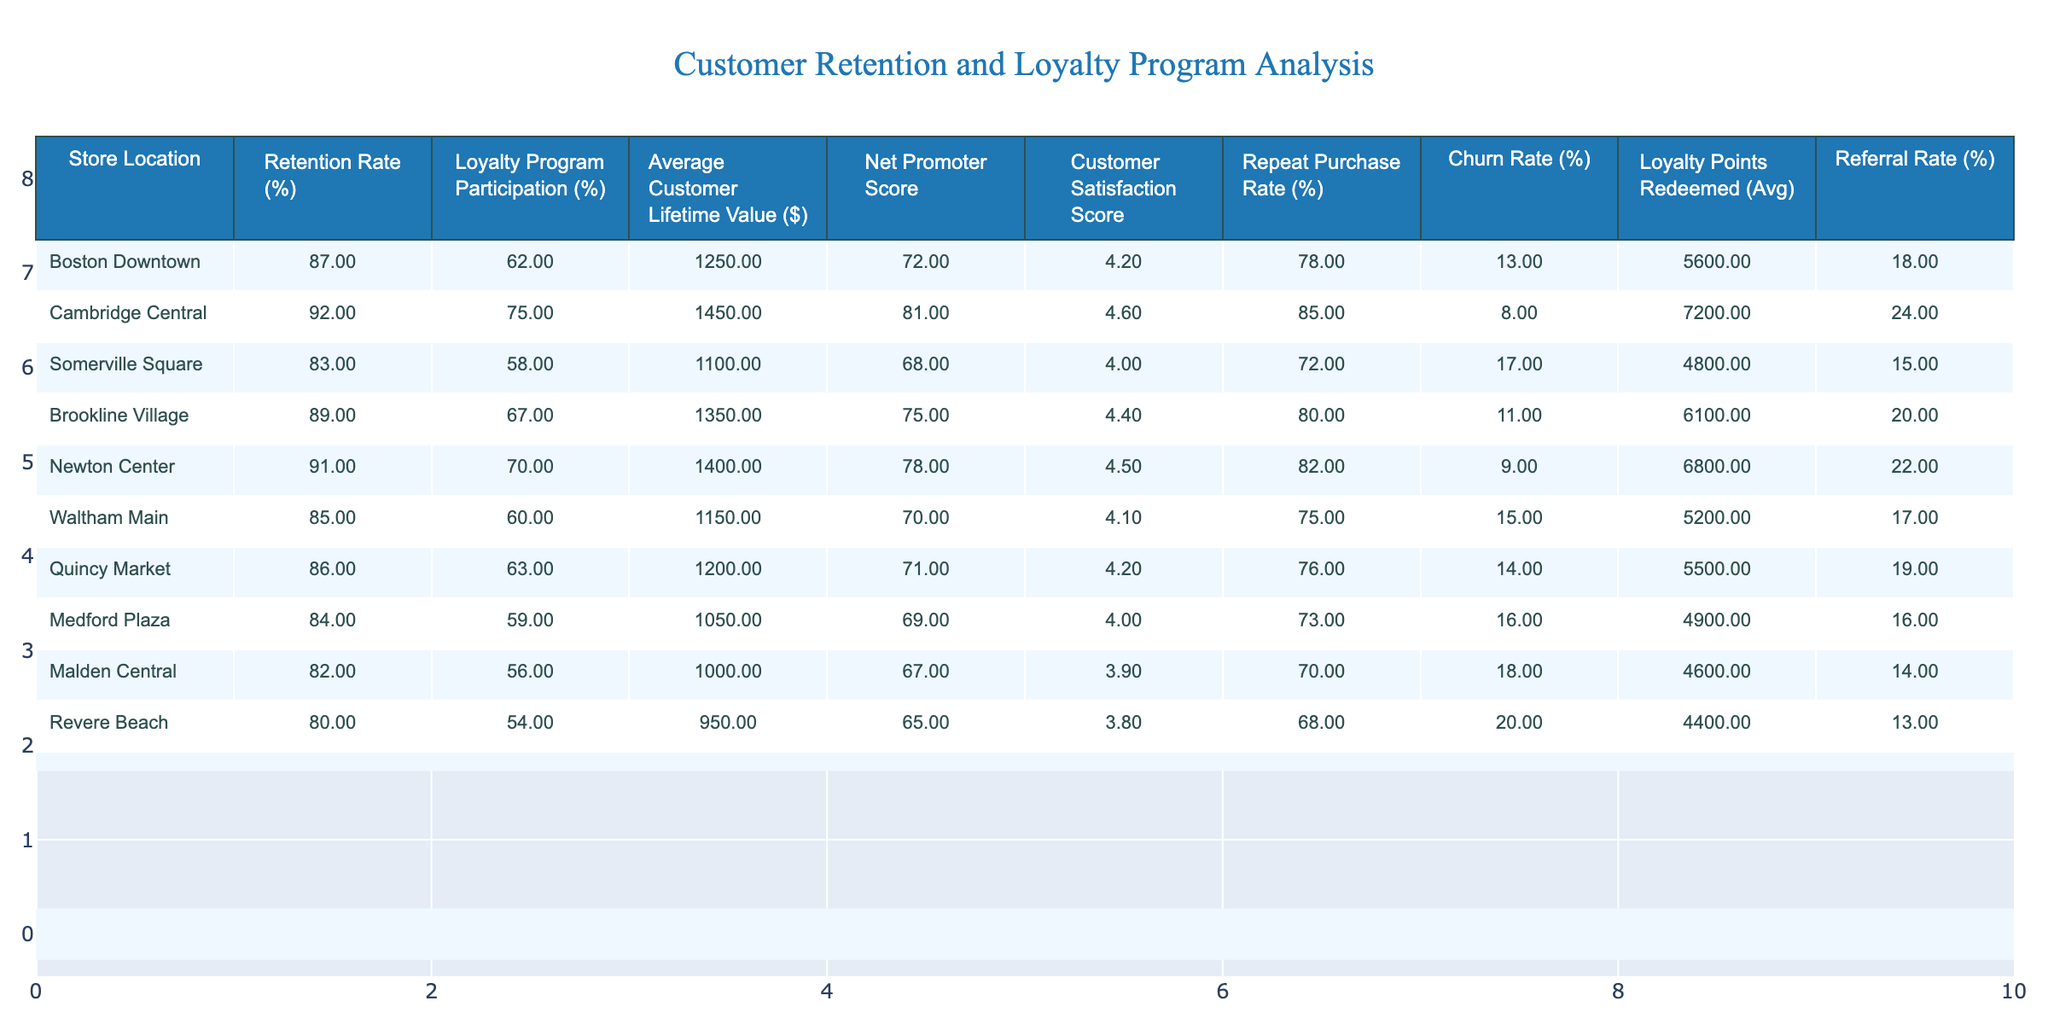What is the retention rate for the store located in Quincy Market? Referring to the table, the retention rate for Quincy Market is listed directly in the "Retention Rate (%)" column.
Answer: 86% Which store has the highest loyalty program participation rate? By comparing the values in the "Loyalty Program Participation (%)" column, Cambridge Central has the highest value at 75%.
Answer: Cambridge Central What is the average customer lifetime value for Brookline Village? The table directly shows that the average customer lifetime value for Brookline Village is $1350 in the "Average Customer Lifetime Value ($)" column.
Answer: 1350 Is the churn rate for Malden Central greater than that for Newton Center? The churn rate for Malden Central is 18%, and for Newton Center, it is 9%. Since 18% is greater than 9%, the statement is true.
Answer: Yes What is the difference in average customer lifetime value between the store with the highest retention rate and the store with the lowest retention rate? The store with the highest retention rate is Cambridge Central ($1450), and the one with the lowest retention rate is Revere Beach ($950). The difference is $1450 - $950 = $500.
Answer: 500 Which store has a Net Promoter Score of 69 or lower? Looking at the "Net Promoter Score" column, Revere Beach has a score of 65, which is the only store with a score of 69 or lower.
Answer: Revere Beach What is the average loyalty program participation rate for all the stores? To calculate this, add all the loyalty program participation rates: 62 + 75 + 58 + 67 + 70 + 60 + 63 + 59 + 56 + 54 =  495. Divide this sum by the number of stores (10) to get an average of 49.5%.
Answer: 49.5% Which store has the highest customer satisfaction score, and what is that score? The table shows that Cambridge Central has the highest customer satisfaction score of 4.6 in the "Customer Satisfaction Score" column.
Answer: 4.6 What is the total number of loyalty points redeemed across all stores? The loyalty points for all stores in the "Loyalty Points Redeemed (Avg)" column are: 5600 + 7200 + 4800 + 6100 + 6800 + 5200 + 5500 + 4900 + 4600 + 4400 =  52000 loyalty points.
Answer: 52000 Is the repeat purchase rate in Somerville Square higher than the average for all stores? The average repeat purchase rate can be calculated: (78 + 85 + 72 + 80 + 82 + 75 + 76 + 73 + 70 + 68) / 10 = 75.7. Somerville Square has a repeat purchase rate of 72%, which is lower than 75.7%.
Answer: No 